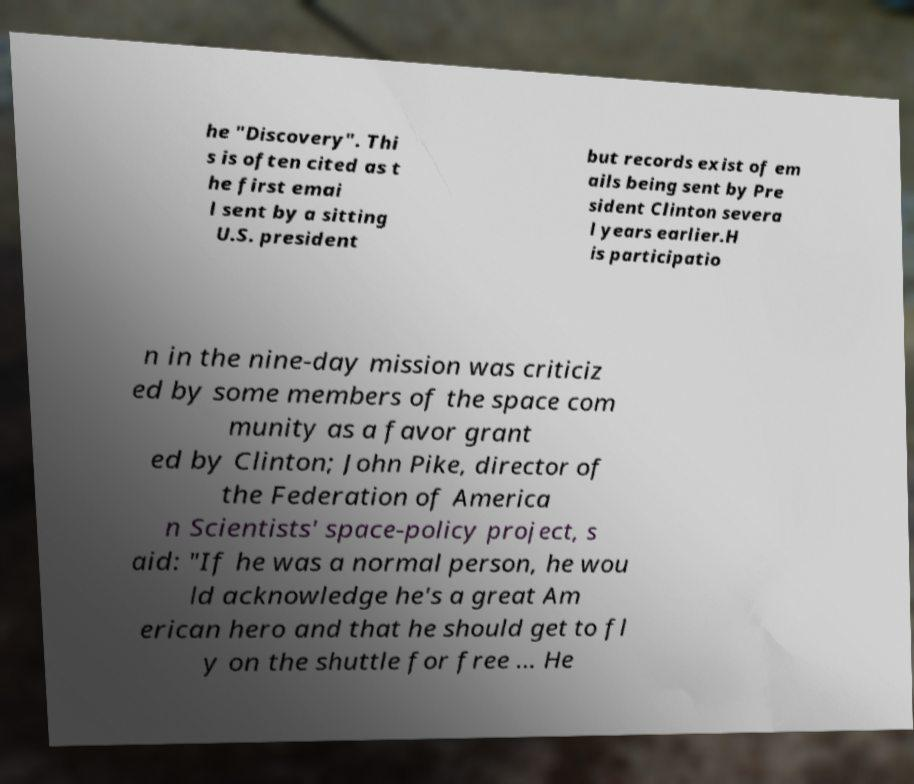Please read and relay the text visible in this image. What does it say? he "Discovery". Thi s is often cited as t he first emai l sent by a sitting U.S. president but records exist of em ails being sent by Pre sident Clinton severa l years earlier.H is participatio n in the nine-day mission was criticiz ed by some members of the space com munity as a favor grant ed by Clinton; John Pike, director of the Federation of America n Scientists' space-policy project, s aid: "If he was a normal person, he wou ld acknowledge he's a great Am erican hero and that he should get to fl y on the shuttle for free ... He 